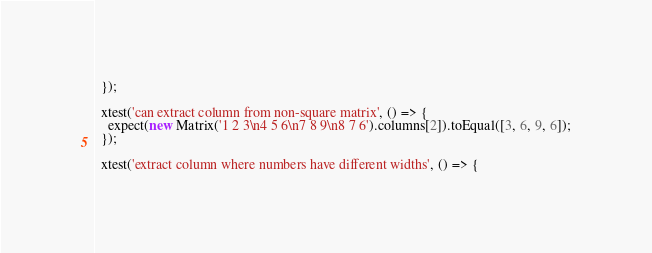<code> <loc_0><loc_0><loc_500><loc_500><_JavaScript_>  });

  xtest('can extract column from non-square matrix', () => {
    expect(new Matrix('1 2 3\n4 5 6\n7 8 9\n8 7 6').columns[2]).toEqual([3, 6, 9, 6]);
  });

  xtest('extract column where numbers have different widths', () => {</code> 